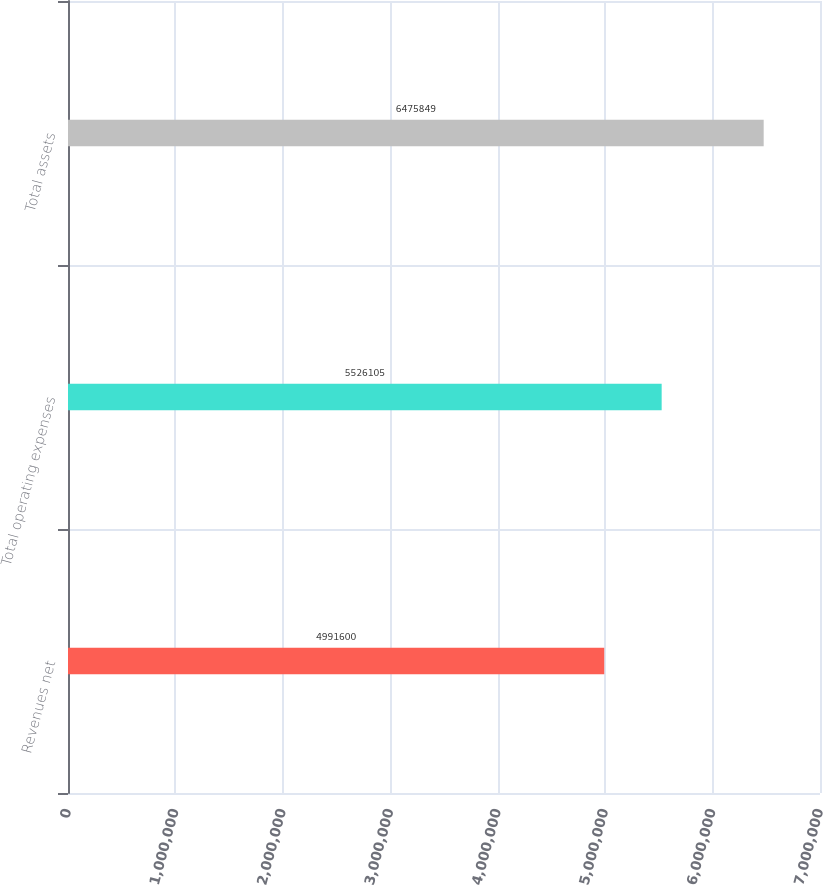Convert chart. <chart><loc_0><loc_0><loc_500><loc_500><bar_chart><fcel>Revenues net<fcel>Total operating expenses<fcel>Total assets<nl><fcel>4.9916e+06<fcel>5.5261e+06<fcel>6.47585e+06<nl></chart> 